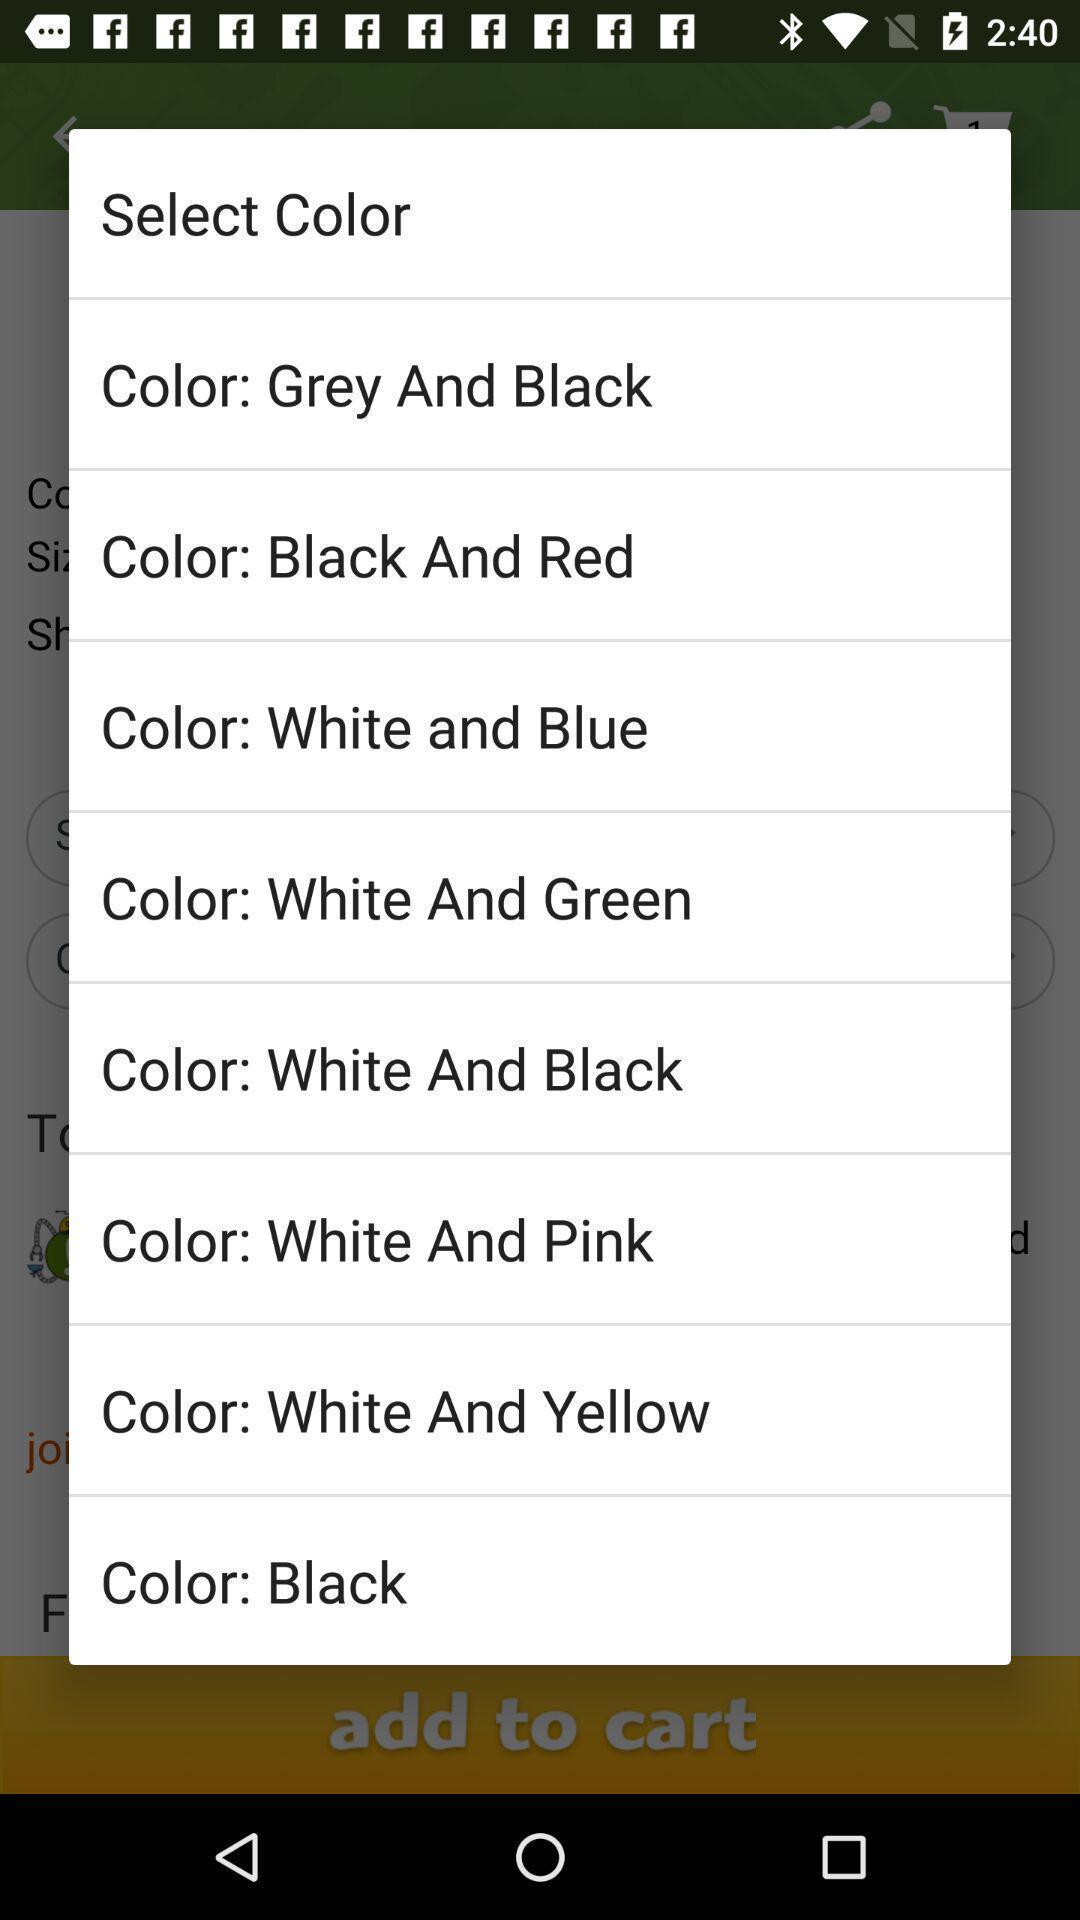Describe the content in this image. Screen showing list of various colors. 